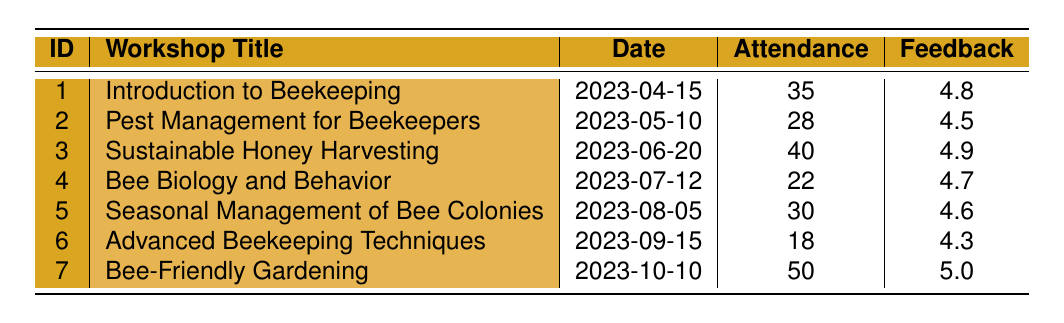What was the date of the "Bee Biology and Behavior" workshop? The table lists various workshops along with their details. By locating the "Bee Biology and Behavior" workshop, we find its corresponding date, which is provided in the "Date" column.
Answer: 2023-07-12 How many attendees were present at the "Sustainable Honey Harvesting" workshop? We can refer to the "Sustainable Honey Harvesting" entry in the table. By looking at the "Attendance" column for this workshop, we find that it had 40 attendees.
Answer: 40 What is the average feedback score of all workshops? To calculate the average, we first sum up all the feedback scores (4.8 + 4.5 + 4.9 + 4.7 + 4.6 + 4.3 + 5.0 = 34.8). There are 7 workshops, so we divide the total score by the number of workshops (34.8 / 7 ≈ 4.97).
Answer: 4.97 Did the "Advanced Beekeeping Techniques" workshop have a feedback score lower than 4.5? By checking the feedback score for the "Advanced Beekeeping Techniques" workshop, we see it is 4.3. Since 4.3 is less than 4.5, the answer to this question is yes.
Answer: Yes Which workshop had the highest attendance and what was the attendance? By reviewing the attendance figures, the "Bee-Friendly Gardening" workshop had the highest attendance, which is noted as 50 in the "Attendance" column.
Answer: Bee-Friendly Gardening, 50 What feedback comment was mentioned for the "Pest Management for Beekeepers" workshop? The table has a feedback comments section for each workshop. By locating the "Pest Management for Beekeepers" entry, we can see the comments provided, one of which is "Great practical tips on treating varroa mites."
Answer: Great practical tips on treating varroa mites How many workshops had a feedback score of 4.5 or higher? To find this, we need to count the workshops with a score of 4.5 or higher. Checking each score reveals that the scores of 4.8, 4.5, 4.9, 4.7, 4.6, 4.3, and 5.0 yield a total of 6 workshops with scores 4.5 or above.
Answer: 6 What is the difference in attendance between the "Introduction to Beekeeping" workshop and the "Advanced Beekeeping Techniques" workshop? First, we identify the attendance for both workshops: 35 for "Introduction to Beekeeping" and 18 for "Advanced Beekeeping Techniques." Then, we find the difference (35 - 18 = 17).
Answer: 17 Did more than 30 people attend the "Seasonal Management of Bee Colonies" workshop? Checking the attendance for this workshop, we see it had 30 attendees. Since 30 is not greater than 30, the answer is no.
Answer: No 